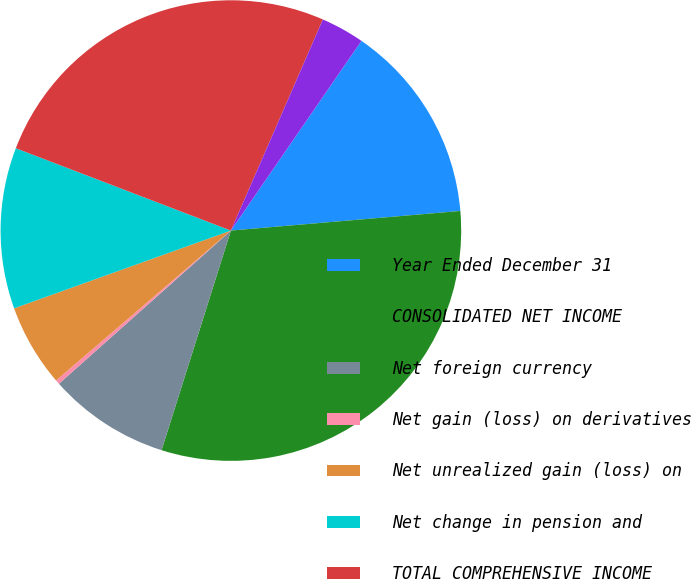Convert chart to OTSL. <chart><loc_0><loc_0><loc_500><loc_500><pie_chart><fcel>Year Ended December 31<fcel>CONSOLIDATED NET INCOME<fcel>Net foreign currency<fcel>Net gain (loss) on derivatives<fcel>Net unrealized gain (loss) on<fcel>Net change in pension and<fcel>TOTAL COMPREHENSIVE INCOME<fcel>Less Comprehensive income<nl><fcel>14.05%<fcel>31.22%<fcel>8.55%<fcel>0.3%<fcel>5.8%<fcel>11.3%<fcel>25.72%<fcel>3.05%<nl></chart> 